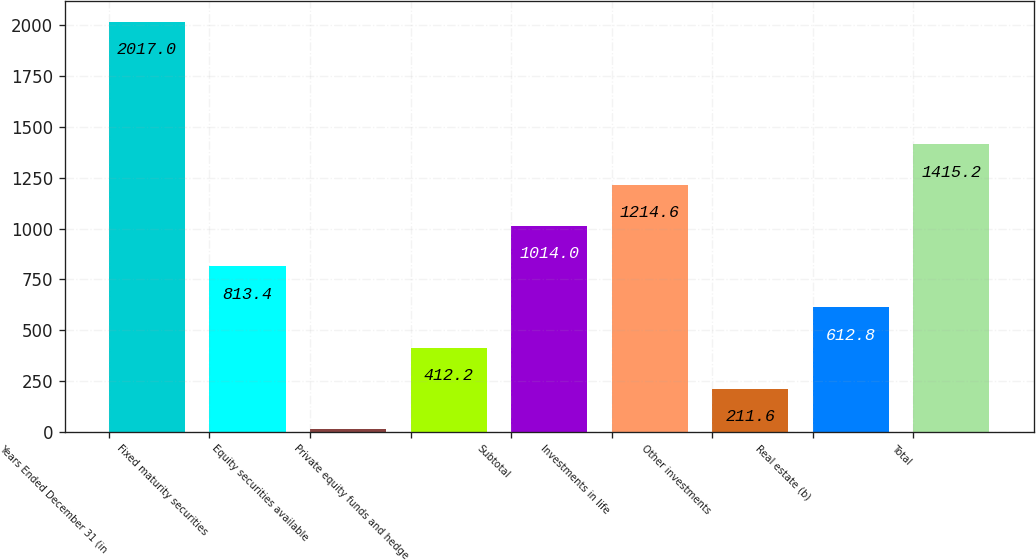<chart> <loc_0><loc_0><loc_500><loc_500><bar_chart><fcel>Years Ended December 31 (in<fcel>Fixed maturity securities<fcel>Equity securities available<fcel>Private equity funds and hedge<fcel>Subtotal<fcel>Investments in life<fcel>Other investments<fcel>Real estate (b)<fcel>Total<nl><fcel>2017<fcel>813.4<fcel>11<fcel>412.2<fcel>1014<fcel>1214.6<fcel>211.6<fcel>612.8<fcel>1415.2<nl></chart> 